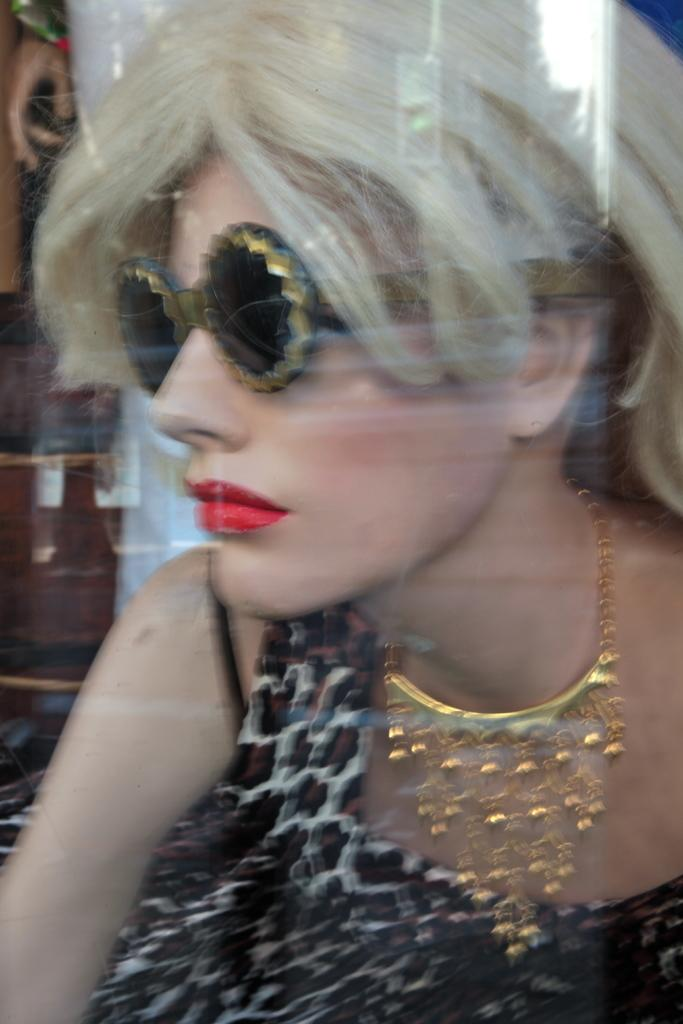What is the main subject in the foreground of the image? There is a woman in the foreground of the image. What accessories is the woman wearing? The woman is wearing a necklace and spectacles. Can you describe the background of the image? The background objects are unclear. What type of robin can be seen in the image? There is no robin present in the image. Does the woman in the image express any feelings of hate? The image does not provide any information about the woman's feelings or emotions. 